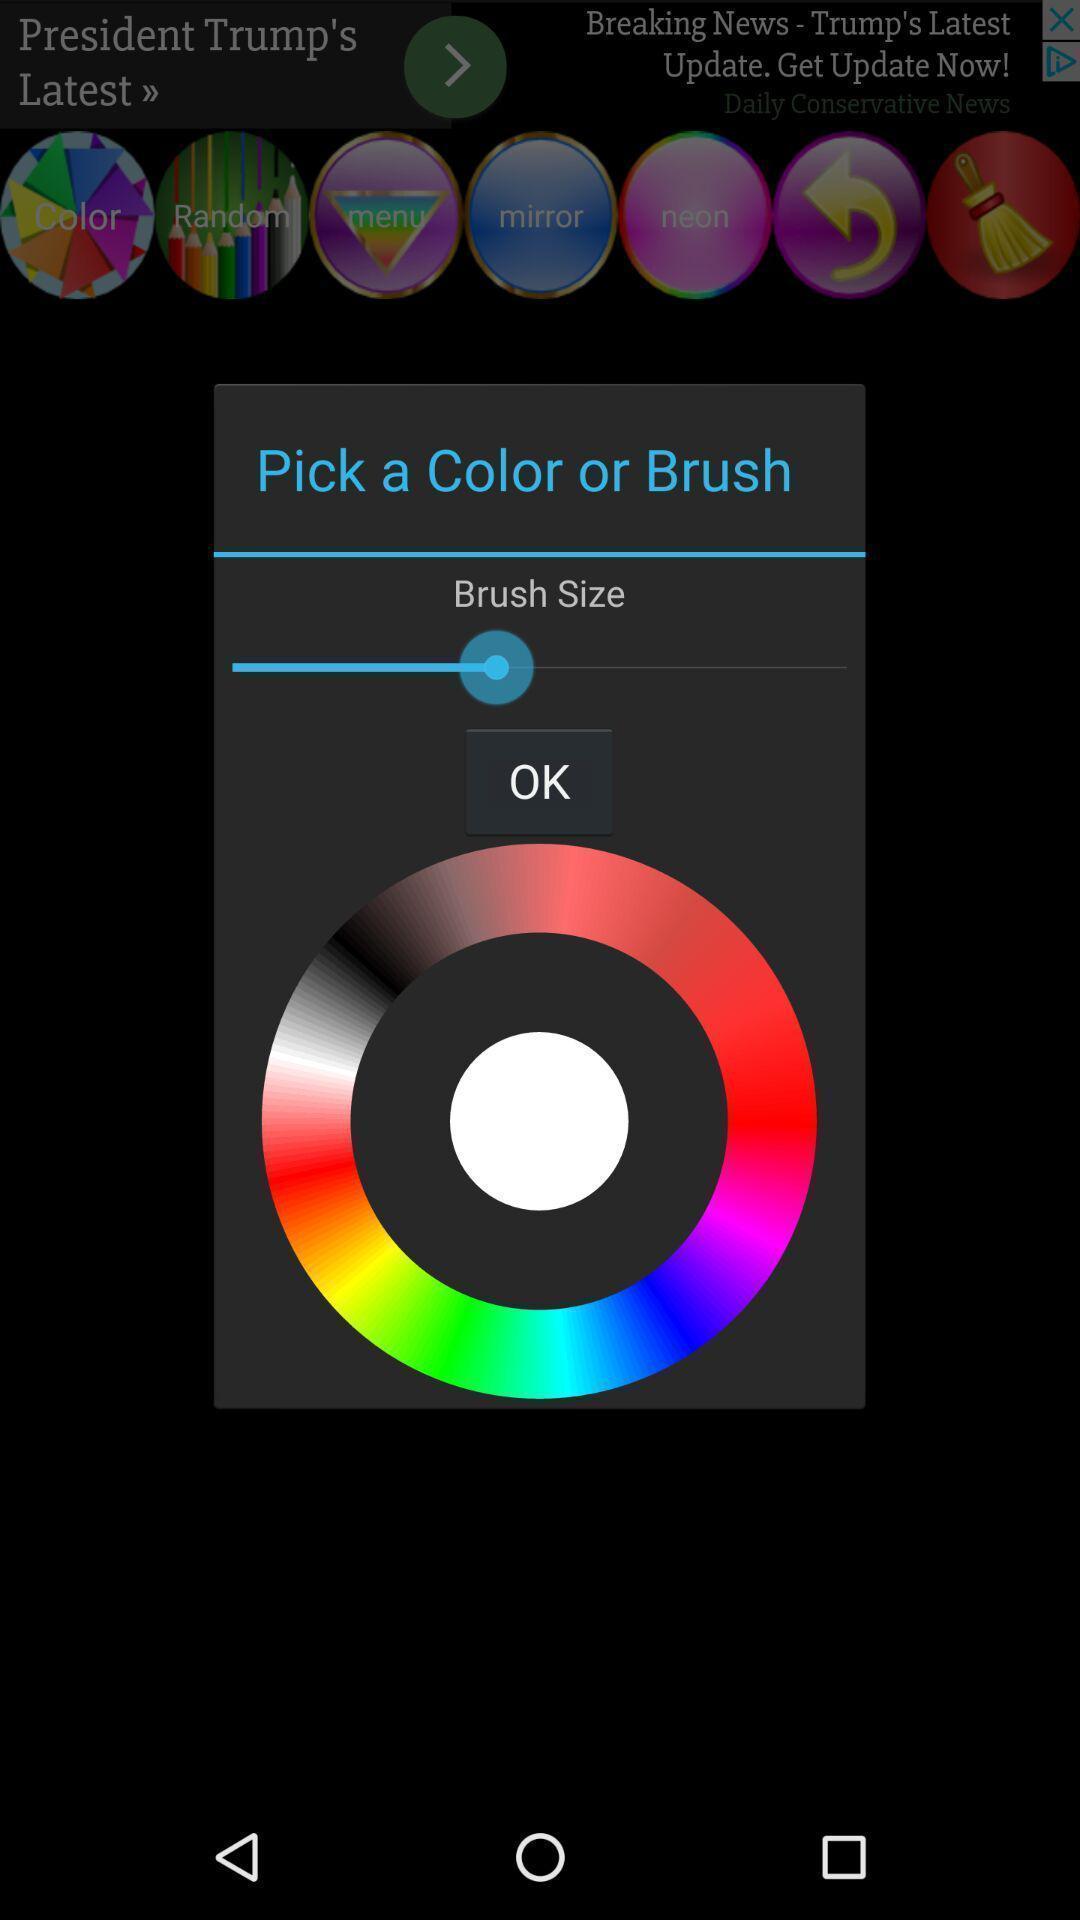Describe the key features of this screenshot. Pop-up asking to choose a colour. 